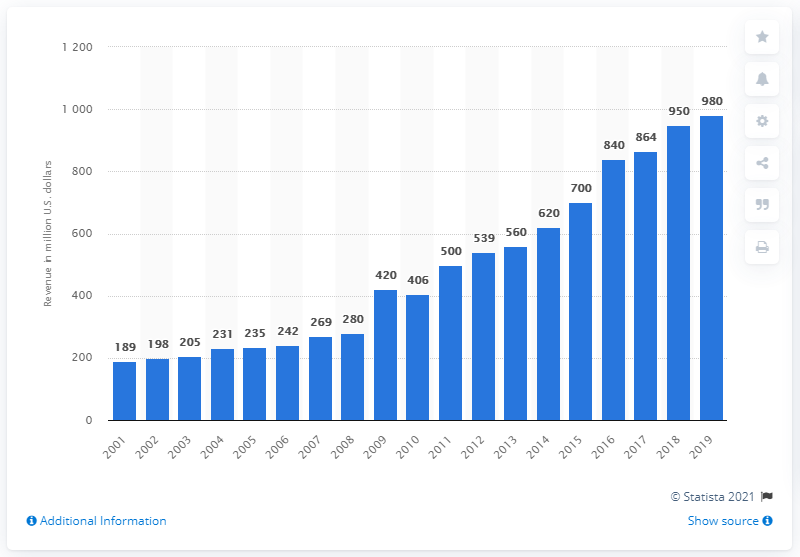Identify some key points in this picture. The revenue of the Dallas Cowboys during the 2019 season was $980 million. 